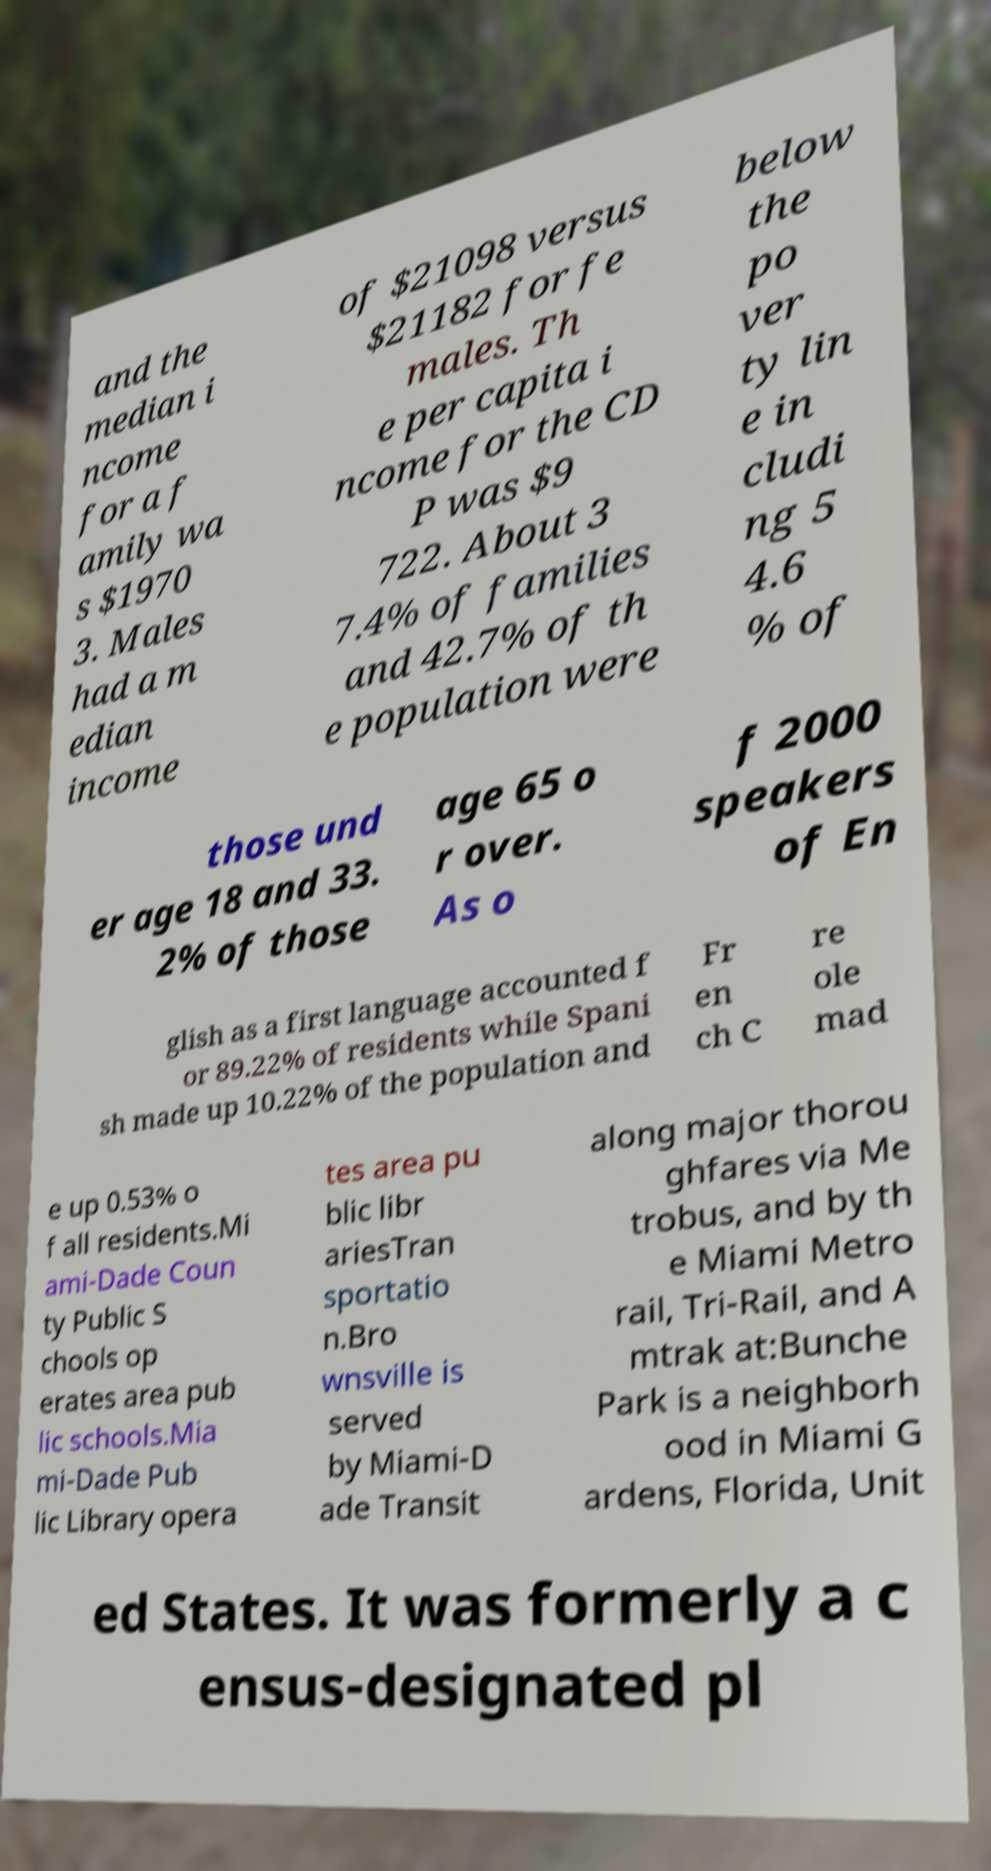Could you assist in decoding the text presented in this image and type it out clearly? and the median i ncome for a f amily wa s $1970 3. Males had a m edian income of $21098 versus $21182 for fe males. Th e per capita i ncome for the CD P was $9 722. About 3 7.4% of families and 42.7% of th e population were below the po ver ty lin e in cludi ng 5 4.6 % of those und er age 18 and 33. 2% of those age 65 o r over. As o f 2000 speakers of En glish as a first language accounted f or 89.22% of residents while Spani sh made up 10.22% of the population and Fr en ch C re ole mad e up 0.53% o f all residents.Mi ami-Dade Coun ty Public S chools op erates area pub lic schools.Mia mi-Dade Pub lic Library opera tes area pu blic libr ariesTran sportatio n.Bro wnsville is served by Miami-D ade Transit along major thorou ghfares via Me trobus, and by th e Miami Metro rail, Tri-Rail, and A mtrak at:Bunche Park is a neighborh ood in Miami G ardens, Florida, Unit ed States. It was formerly a c ensus-designated pl 